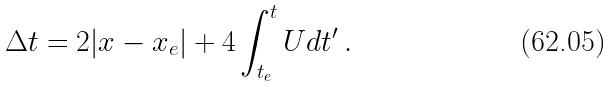<formula> <loc_0><loc_0><loc_500><loc_500>\Delta t = 2 | x - x _ { e } | + 4 \int _ { t _ { e } } ^ { t } U d t ^ { \prime } \, .</formula> 